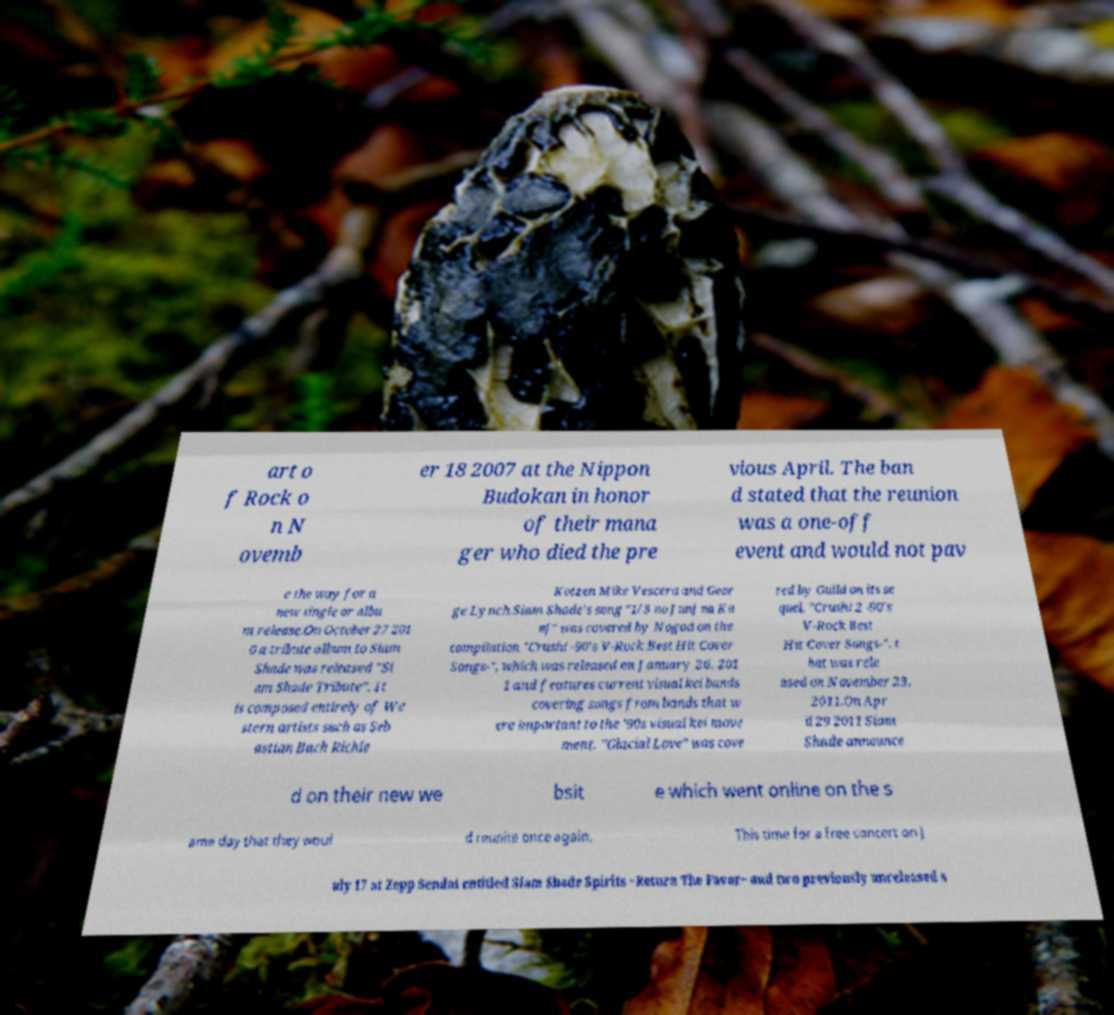Can you read and provide the text displayed in the image?This photo seems to have some interesting text. Can you extract and type it out for me? art o f Rock o n N ovemb er 18 2007 at the Nippon Budokan in honor of their mana ger who died the pre vious April. The ban d stated that the reunion was a one-off event and would not pav e the way for a new single or albu m release.On October 27 201 0 a tribute album to Siam Shade was released "Si am Shade Tribute". It is composed entirely of We stern artists such as Seb astian Bach Richie Kotzen Mike Vescera and Geor ge Lynch.Siam Shade's song "1/3 no Junj na Ka nj" was covered by Nogod on the compilation "Crush! -90's V-Rock Best Hit Cover Songs-", which was released on January 26, 201 1 and features current visual kei bands covering songs from bands that w ere important to the '90s visual kei move ment. "Glacial Love" was cove red by Guild on its se quel, "Crush! 2 -90's V-Rock Best Hit Cover Songs-", t hat was rele ased on November 23, 2011.On Apr il 29 2011 Siam Shade announce d on their new we bsit e which went online on the s ame day that they woul d reunite once again. This time for a free concert on J uly 17 at Zepp Sendai entitled Siam Shade Spirits ~Return The Favor~ and two previously unreleased s 